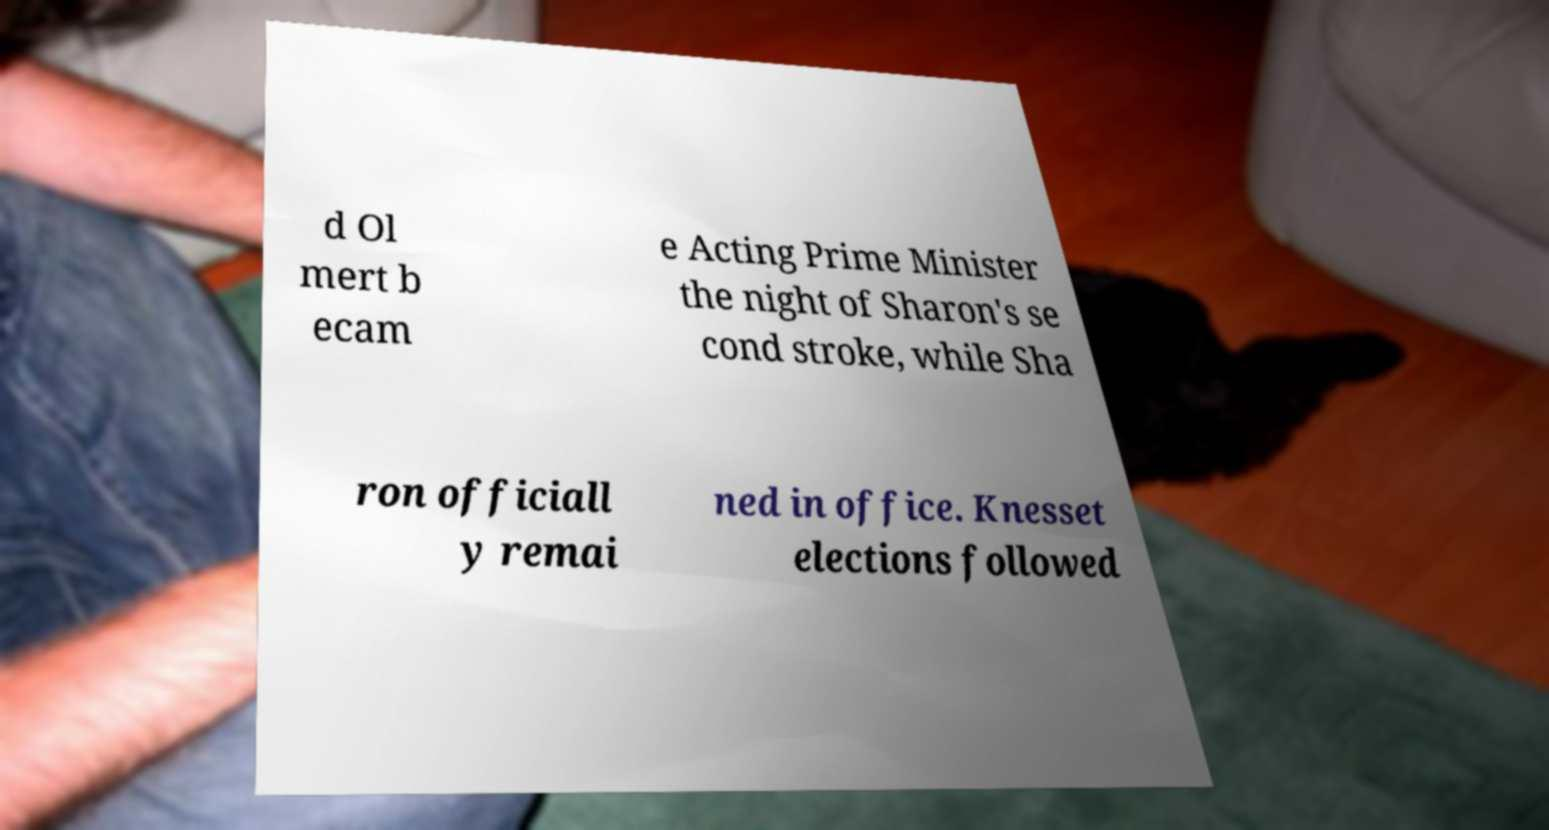What messages or text are displayed in this image? I need them in a readable, typed format. d Ol mert b ecam e Acting Prime Minister the night of Sharon's se cond stroke, while Sha ron officiall y remai ned in office. Knesset elections followed 